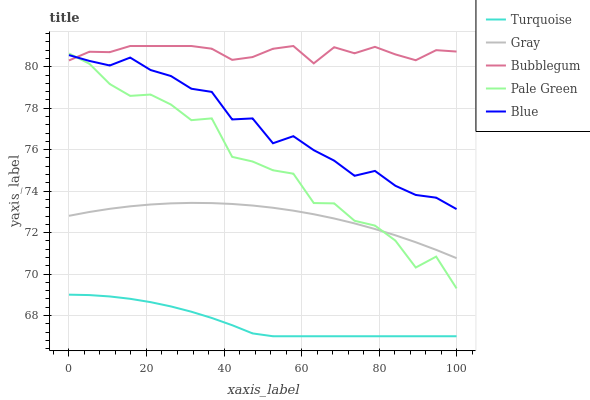Does Turquoise have the minimum area under the curve?
Answer yes or no. Yes. Does Bubblegum have the maximum area under the curve?
Answer yes or no. Yes. Does Gray have the minimum area under the curve?
Answer yes or no. No. Does Gray have the maximum area under the curve?
Answer yes or no. No. Is Gray the smoothest?
Answer yes or no. Yes. Is Pale Green the roughest?
Answer yes or no. Yes. Is Turquoise the smoothest?
Answer yes or no. No. Is Turquoise the roughest?
Answer yes or no. No. Does Gray have the lowest value?
Answer yes or no. No. Does Gray have the highest value?
Answer yes or no. No. Is Turquoise less than Gray?
Answer yes or no. Yes. Is Blue greater than Gray?
Answer yes or no. Yes. Does Turquoise intersect Gray?
Answer yes or no. No. 